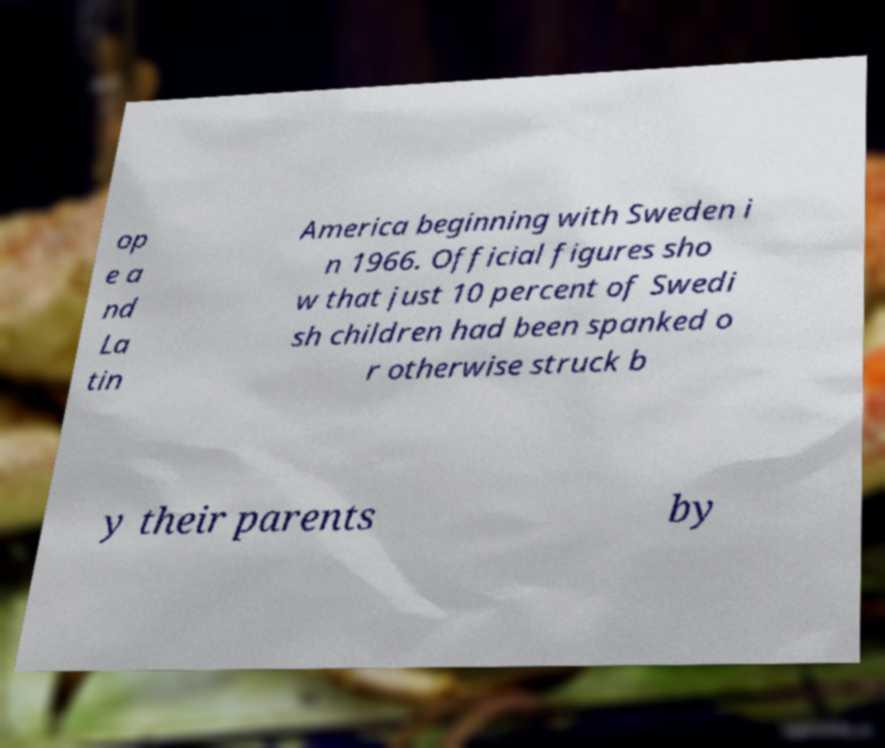What messages or text are displayed in this image? I need them in a readable, typed format. op e a nd La tin America beginning with Sweden i n 1966. Official figures sho w that just 10 percent of Swedi sh children had been spanked o r otherwise struck b y their parents by 